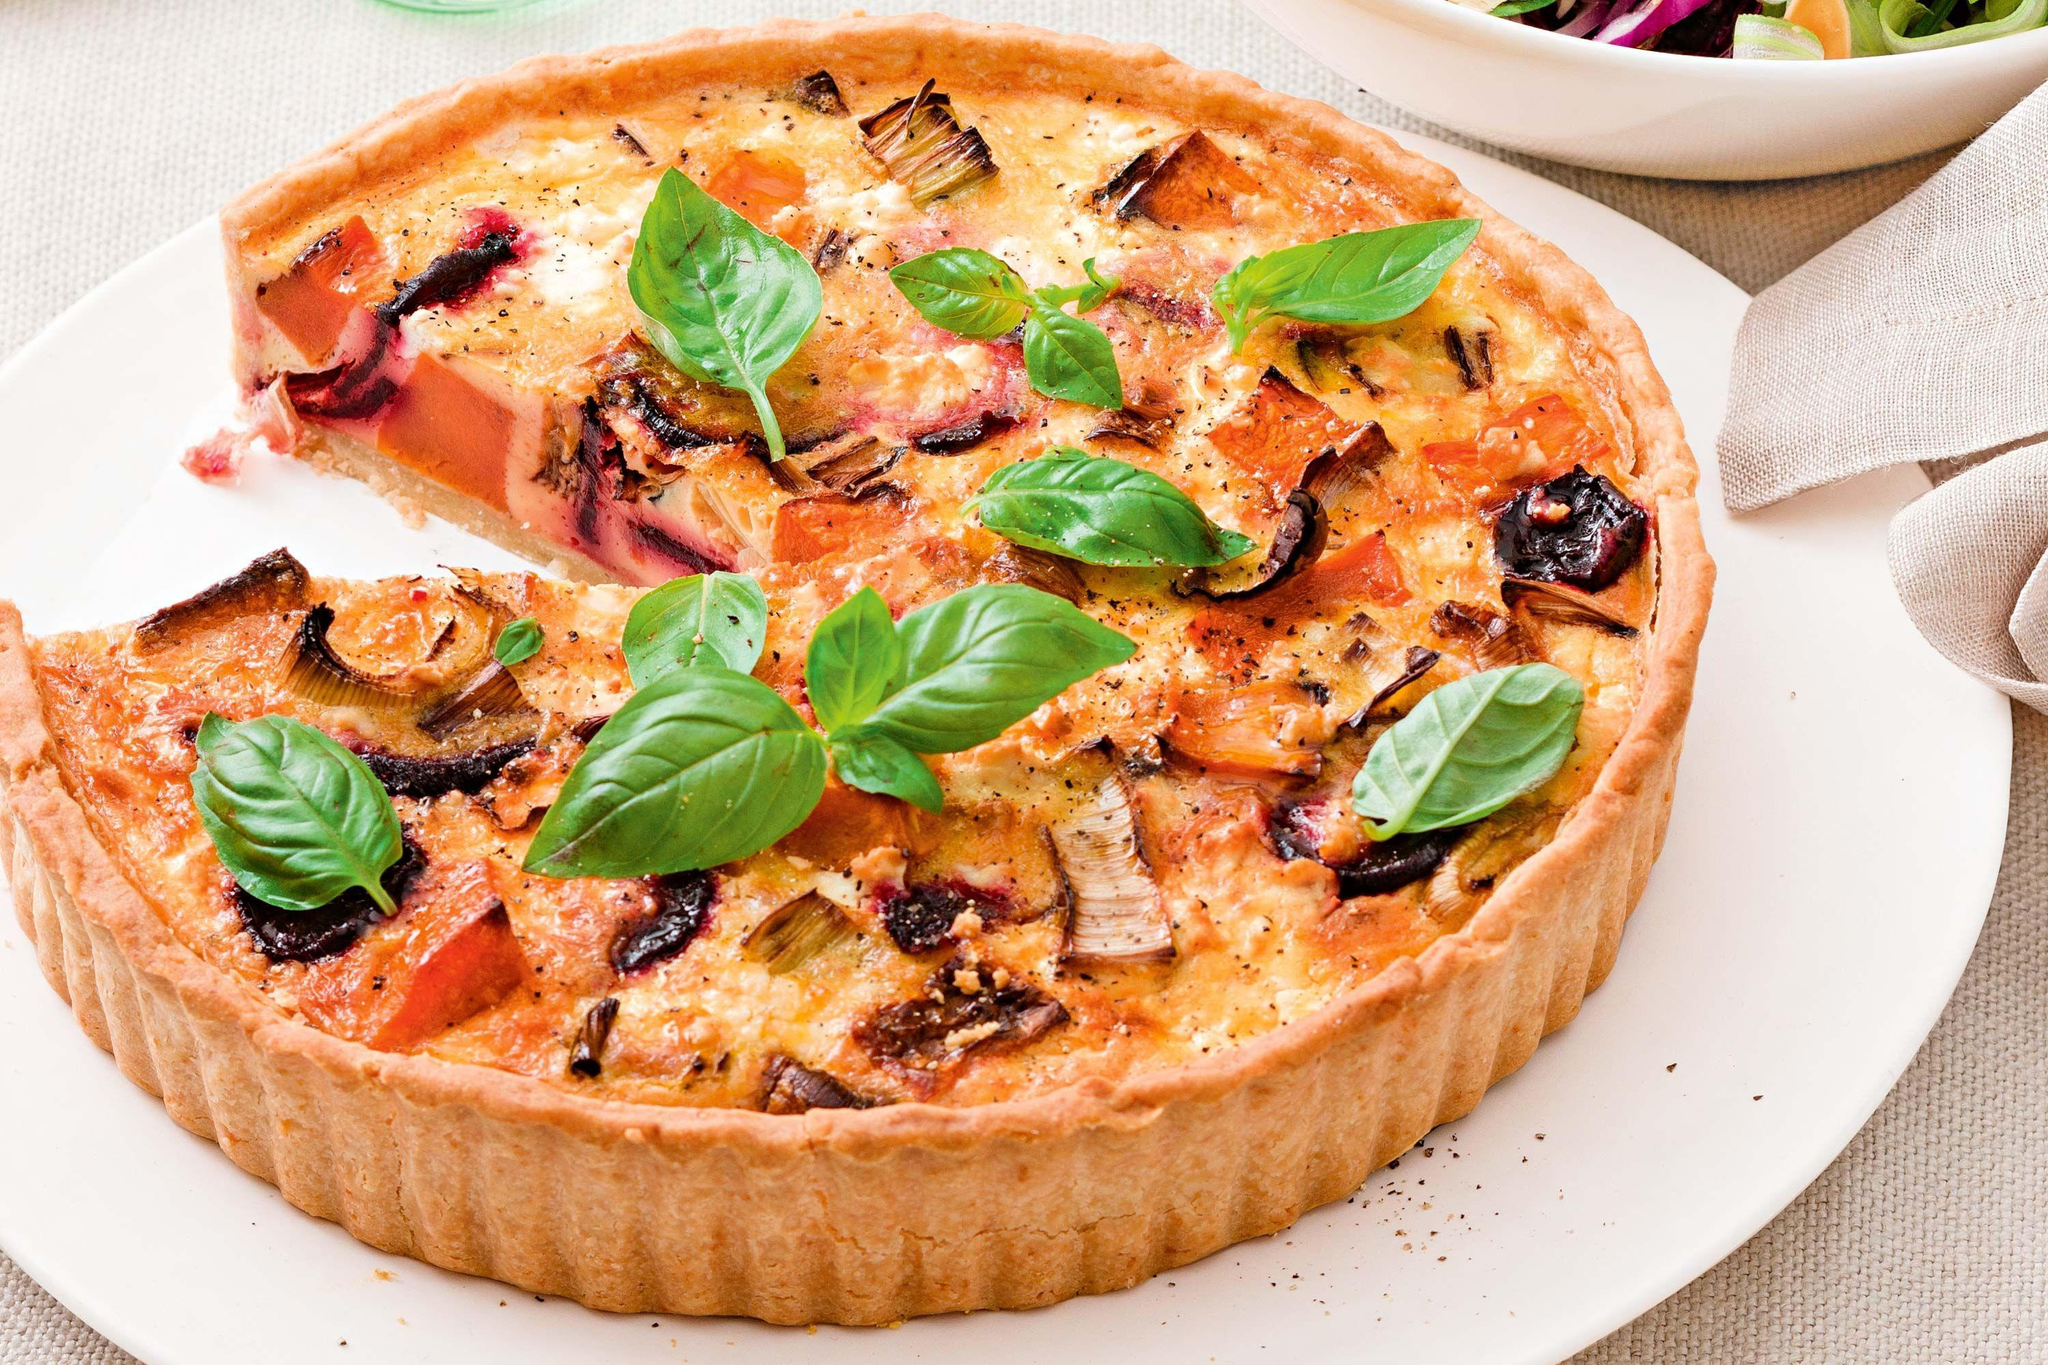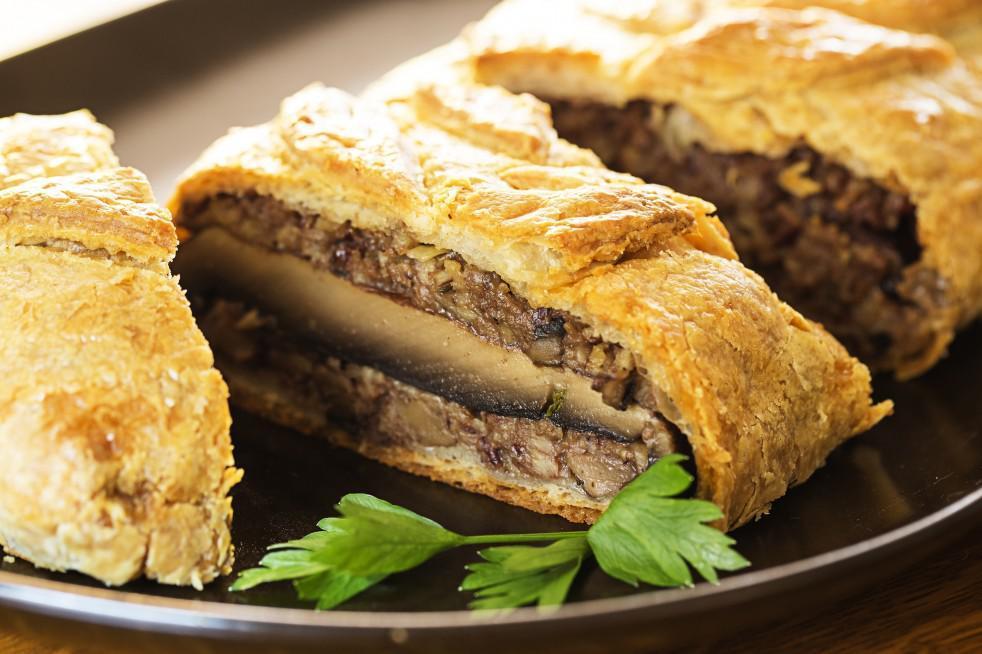The first image is the image on the left, the second image is the image on the right. For the images displayed, is the sentence "The left image features half-circle shapes on a rectangle with edges, and the right image features something shaped like a slice of pie." factually correct? Answer yes or no. No. The first image is the image on the left, the second image is the image on the right. For the images shown, is this caption "In the image on the left, the dough products are arranged neatly on a baking sheet." true? Answer yes or no. No. 